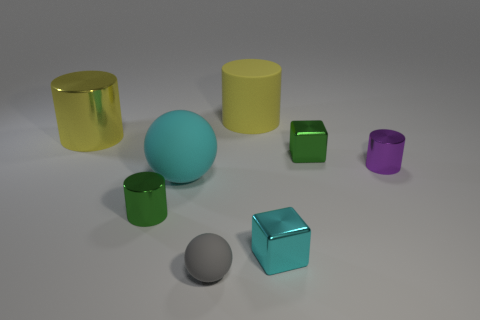Does the gray matte thing that is in front of the cyan ball have the same size as the matte cylinder left of the purple cylinder? While both objects appear to have similar dimensions, the gray matte object in front of the cyan ball is slightly larger in height compared to the matte cylinder to the left of the purple cylinder. However, if we consider the proportions, they are not identical, which indicates they do not have the same size. 